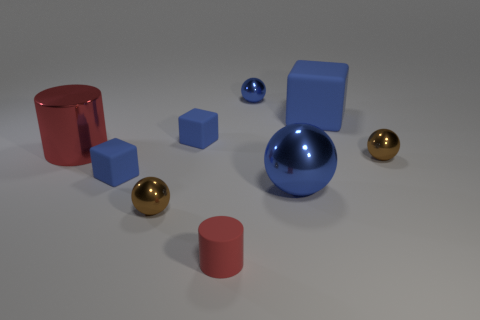What is the size of the blue matte cube that is both behind the big red metallic thing and left of the big blue matte cube?
Offer a very short reply. Small. There is a small thing right of the block right of the tiny red thing; what shape is it?
Offer a very short reply. Sphere. Is there anything else that has the same color as the tiny rubber cylinder?
Offer a very short reply. Yes. What is the shape of the tiny brown shiny object right of the big blue metallic thing?
Your answer should be very brief. Sphere. What is the shape of the object that is both to the right of the big blue sphere and behind the large cylinder?
Keep it short and to the point. Cube. What number of purple objects are either big rubber blocks or small objects?
Your answer should be compact. 0. There is a sphere that is behind the big red object; is it the same color as the large shiny cylinder?
Your answer should be compact. No. There is a rubber thing that is right of the blue sphere behind the big red object; what size is it?
Offer a terse response. Large. What material is the block that is the same size as the metallic cylinder?
Make the answer very short. Rubber. How many other objects are there of the same size as the red shiny cylinder?
Provide a succinct answer. 2. 